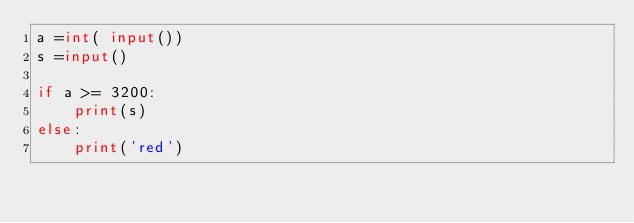Convert code to text. <code><loc_0><loc_0><loc_500><loc_500><_Python_>a =int( input())
s =input()

if a >= 3200:
    print(s)
else:
    print('red')
</code> 